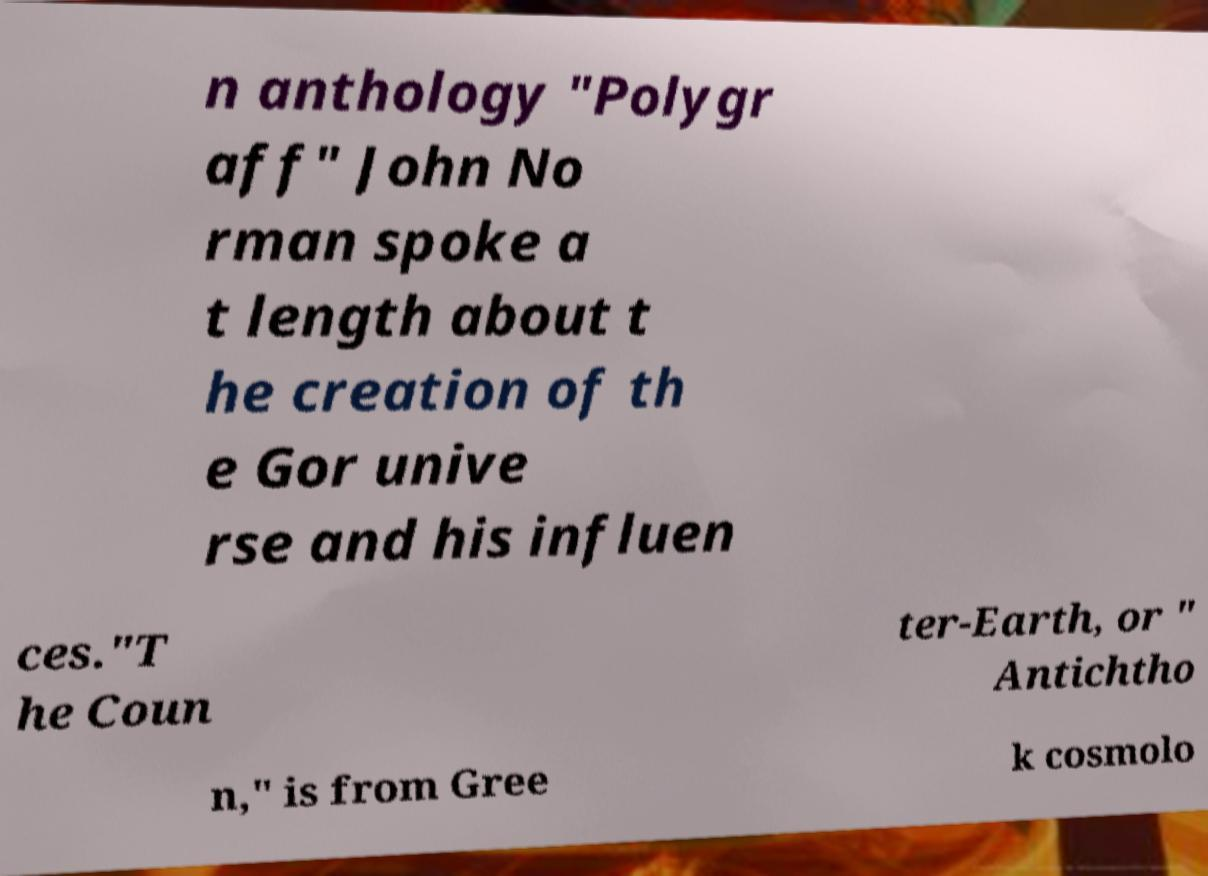Could you extract and type out the text from this image? n anthology "Polygr aff" John No rman spoke a t length about t he creation of th e Gor unive rse and his influen ces."T he Coun ter-Earth, or " Antichtho n," is from Gree k cosmolo 